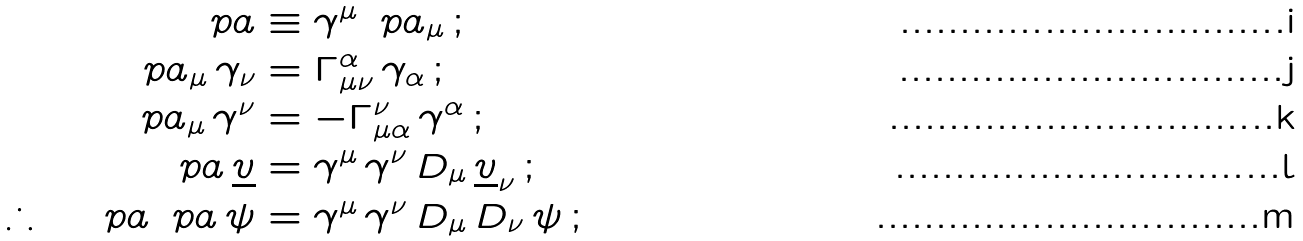Convert formula to latex. <formula><loc_0><loc_0><loc_500><loc_500>\ p a & \equiv \gamma ^ { \mu } \, \ p a _ { \mu } \, ; \\ \ p a _ { \mu } \, \gamma _ { \nu } & = \Gamma ^ { \alpha } _ { \mu \nu } \, \gamma _ { \alpha } \, ; \\ \ p a _ { \mu } \, \gamma ^ { \nu } & = - \Gamma ^ { \nu } _ { \mu \alpha } \, \gamma ^ { \alpha } \, ; \\ \ p a \, \underline { v } & = \gamma ^ { \mu } \, \gamma ^ { \nu } \, D _ { \mu } \, \underline { v } _ { \nu } \, ; \\ \therefore \quad \ p a \, \ p a \, \psi & = \gamma ^ { \mu } \, \gamma ^ { \nu } \, D _ { \mu } \, D _ { \nu } \, \psi \, ;</formula> 